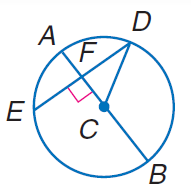Question: If D E = 60 and F C = 16, find A B.
Choices:
A. 16
B. 34
C. 60
D. 68
Answer with the letter. Answer: D Question: If A B = 60 and D E = 48, find C F.
Choices:
A. 12
B. 18
C. 24
D. 30
Answer with the letter. Answer: B 